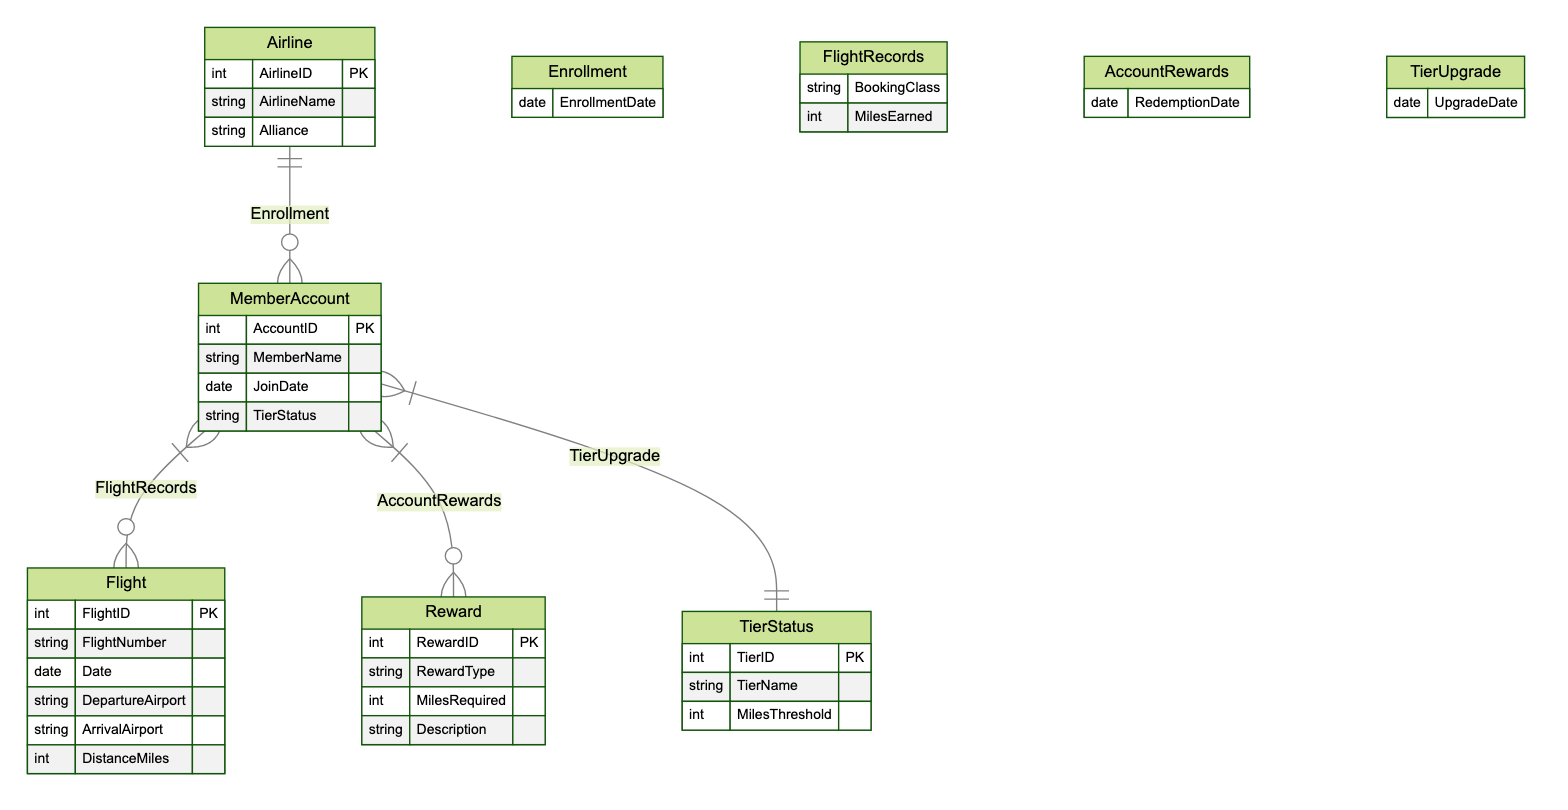What does the Enrollment relationship connect? The Enrollment relationship connects the Airline entity to the MemberAccount entity, indicating a link between an airline and its member accounts.
Answer: Airline and MemberAccount How many entities are in the diagram? There are five entities depicted in the diagram, which are Airline, MemberAccount, Flight, Reward, and TierStatus.
Answer: 5 What attribute is common between MemberAccount and Flight? The common attributes regarding the Flight entity related to the MemberAccount concern the FlightRecords, which include BookingClass and MilesEarned. Thus, the answer is related to the records of flights taken by the member.
Answer: FlightRecords What does the TierUpgrade relationship link? The TierUpgrade relationship links MemberAccount with TierStatus, representing how member accounts can be upgraded to a different tier based on their activity and miles earned.
Answer: MemberAccount and TierStatus How many attributes does the Reward entity have? The Reward entity has four attributes: RewardID, RewardType, MilesRequired, and Description, which detail the rewards available to the members.
Answer: 4 What is the minimum required miles for a Reward? The minimum required miles for a reward can be found in the MilesRequired attribute of the Reward entity. The specific value would depend on the individual rewards offered, but it's referenced directly within this attribute.
Answer: Variable (based on reward) Which entity is related to the AccountRewards relationship? The AccountRewards relationship relates the MemberAccount entity to the Reward entity, indicating that members can redeem their flight miles for rewards.
Answer: Reward What indicates the relationship type of TierStatus to MemberAccount? The relationship type between TierStatus and MemberAccount is indicated as a one-to-many relationship, where multiple accounts can correspond to a single tier status. The relationship name is TierUpgrade.
Answer: TierUpgrade How many attributes does the Enrollment relationship have? The Enrollment relationship has one attribute, which is EnrollmentDate, indicating when a member account was enrolled with the airline.
Answer: 1 